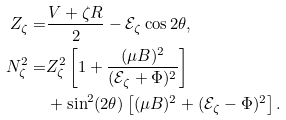<formula> <loc_0><loc_0><loc_500><loc_500>Z _ { \zeta } = & \frac { V + \zeta R } { 2 } - \mathcal { E } _ { \zeta } \cos 2 \theta , \\ N _ { \zeta } ^ { 2 } = & Z _ { \zeta } ^ { 2 } \left [ 1 + \frac { ( \mu B ) ^ { 2 } } { ( \mathcal { E } _ { \zeta } + \Phi ) ^ { 2 } } \right ] \\ & + \sin ^ { 2 } ( 2 \theta ) \left [ ( \mu B ) ^ { 2 } + ( \mathcal { E } _ { \zeta } - \Phi ) ^ { 2 } \right ] .</formula> 